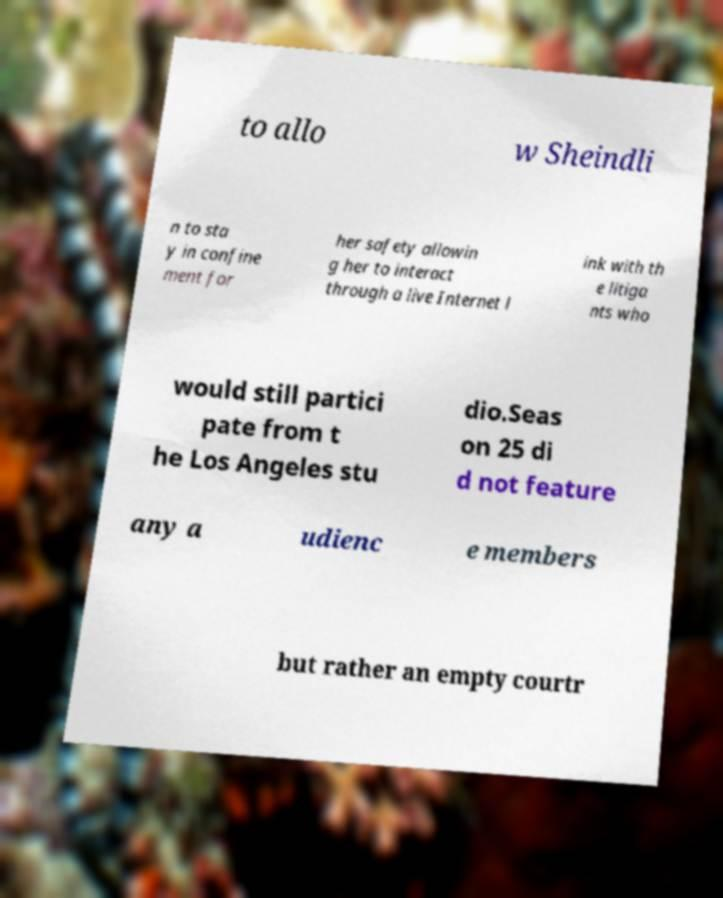Please identify and transcribe the text found in this image. to allo w Sheindli n to sta y in confine ment for her safety allowin g her to interact through a live Internet l ink with th e litiga nts who would still partici pate from t he Los Angeles stu dio.Seas on 25 di d not feature any a udienc e members but rather an empty courtr 